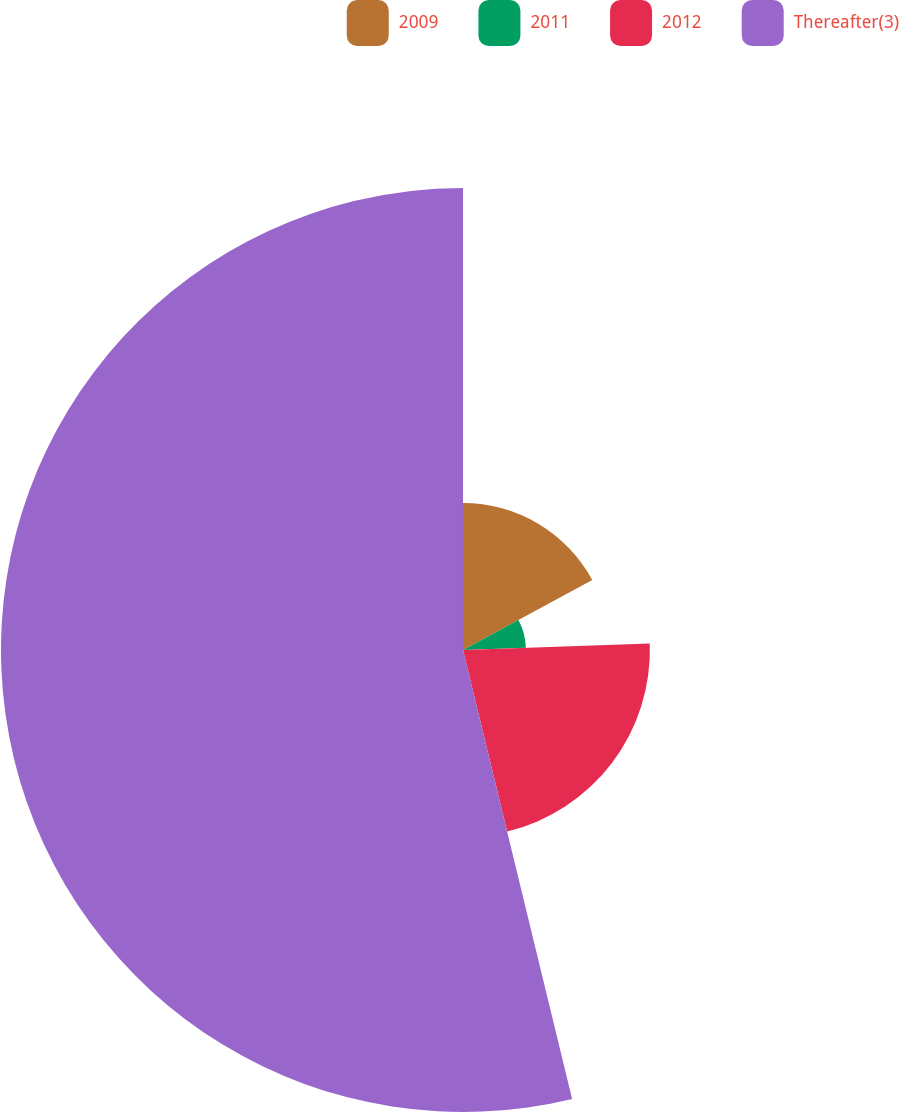Convert chart to OTSL. <chart><loc_0><loc_0><loc_500><loc_500><pie_chart><fcel>2009<fcel>2011<fcel>2012<fcel>Thereafter(3)<nl><fcel>17.11%<fcel>7.33%<fcel>21.76%<fcel>53.79%<nl></chart> 